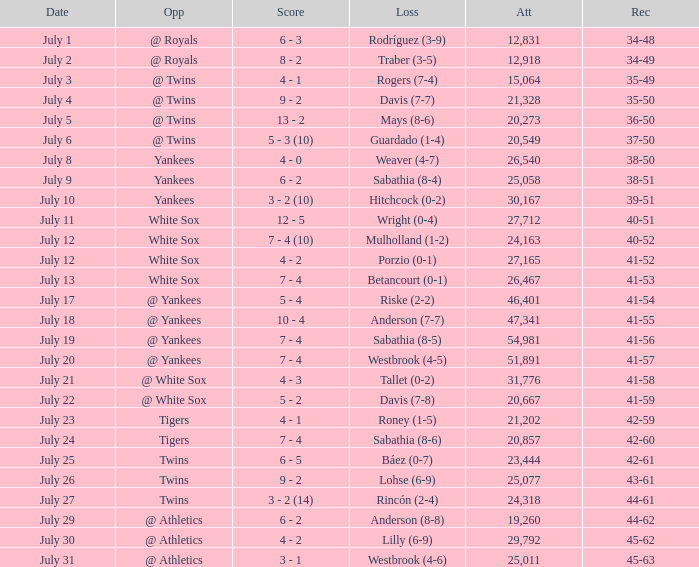Which Record has an Opponent of twins, and a Date of july 25? 42-61. 